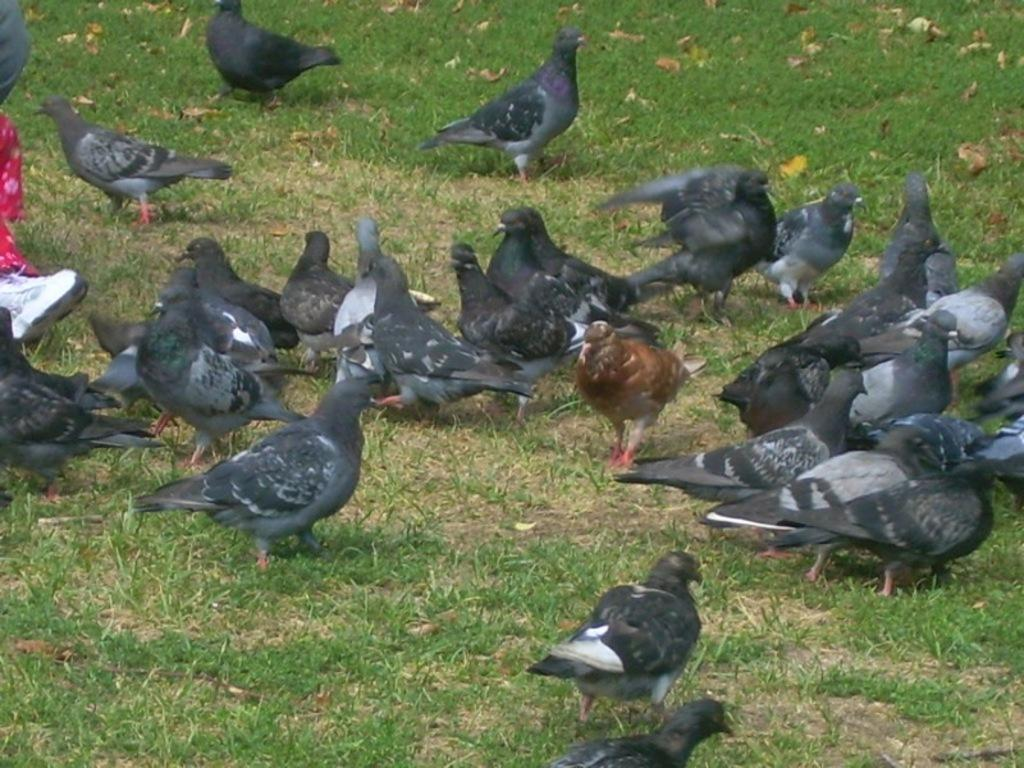What type of animals can be seen on the grass in the image? There are pigeons on the grass in the image. Where are the pigeons located in relation to the image? The pigeons are at the bottom of the image. Can you describe any human presence in the image? There are two person's legs visible on the left side of the image. What type of pin can be seen on the pigeon's wing in the image? There is no pin visible on any of the pigeons in the image. What kind of test is being conducted on the pigeons in the image? There is no test being conducted on the pigeons in the image; they are simply resting on the grass. 